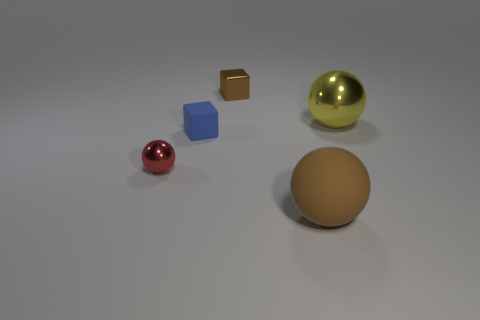Are there an equal number of tiny blue rubber cubes that are behind the blue cube and tiny red spheres behind the big brown matte thing?
Keep it short and to the point. No. How many other objects are there of the same color as the metallic cube?
Your response must be concise. 1. Are there an equal number of red metal balls that are right of the tiny red shiny object and small brown things?
Your response must be concise. No. Do the brown matte ball and the yellow shiny thing have the same size?
Keep it short and to the point. Yes. There is a object that is both in front of the tiny blue rubber thing and right of the blue object; what material is it?
Your response must be concise. Rubber. What number of other large metal objects have the same shape as the yellow object?
Your answer should be compact. 0. What is the material of the large object that is in front of the blue thing?
Keep it short and to the point. Rubber. Are there fewer brown rubber objects behind the blue block than matte spheres?
Keep it short and to the point. Yes. Is the shape of the brown metallic object the same as the small blue rubber object?
Offer a very short reply. Yes. Are there any other things that are the same shape as the tiny matte thing?
Give a very brief answer. Yes. 